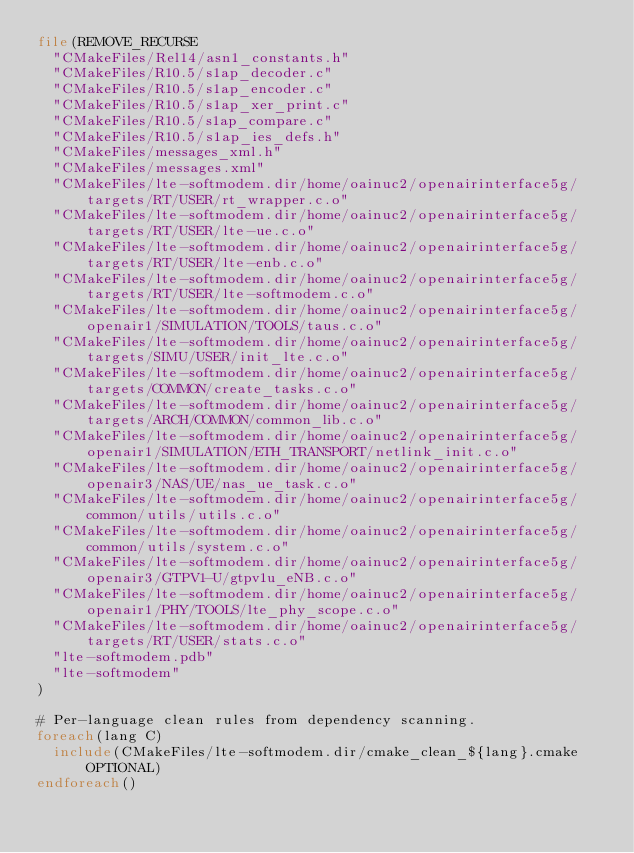<code> <loc_0><loc_0><loc_500><loc_500><_CMake_>file(REMOVE_RECURSE
  "CMakeFiles/Rel14/asn1_constants.h"
  "CMakeFiles/R10.5/s1ap_decoder.c"
  "CMakeFiles/R10.5/s1ap_encoder.c"
  "CMakeFiles/R10.5/s1ap_xer_print.c"
  "CMakeFiles/R10.5/s1ap_compare.c"
  "CMakeFiles/R10.5/s1ap_ies_defs.h"
  "CMakeFiles/messages_xml.h"
  "CMakeFiles/messages.xml"
  "CMakeFiles/lte-softmodem.dir/home/oainuc2/openairinterface5g/targets/RT/USER/rt_wrapper.c.o"
  "CMakeFiles/lte-softmodem.dir/home/oainuc2/openairinterface5g/targets/RT/USER/lte-ue.c.o"
  "CMakeFiles/lte-softmodem.dir/home/oainuc2/openairinterface5g/targets/RT/USER/lte-enb.c.o"
  "CMakeFiles/lte-softmodem.dir/home/oainuc2/openairinterface5g/targets/RT/USER/lte-softmodem.c.o"
  "CMakeFiles/lte-softmodem.dir/home/oainuc2/openairinterface5g/openair1/SIMULATION/TOOLS/taus.c.o"
  "CMakeFiles/lte-softmodem.dir/home/oainuc2/openairinterface5g/targets/SIMU/USER/init_lte.c.o"
  "CMakeFiles/lte-softmodem.dir/home/oainuc2/openairinterface5g/targets/COMMON/create_tasks.c.o"
  "CMakeFiles/lte-softmodem.dir/home/oainuc2/openairinterface5g/targets/ARCH/COMMON/common_lib.c.o"
  "CMakeFiles/lte-softmodem.dir/home/oainuc2/openairinterface5g/openair1/SIMULATION/ETH_TRANSPORT/netlink_init.c.o"
  "CMakeFiles/lte-softmodem.dir/home/oainuc2/openairinterface5g/openair3/NAS/UE/nas_ue_task.c.o"
  "CMakeFiles/lte-softmodem.dir/home/oainuc2/openairinterface5g/common/utils/utils.c.o"
  "CMakeFiles/lte-softmodem.dir/home/oainuc2/openairinterface5g/common/utils/system.c.o"
  "CMakeFiles/lte-softmodem.dir/home/oainuc2/openairinterface5g/openair3/GTPV1-U/gtpv1u_eNB.c.o"
  "CMakeFiles/lte-softmodem.dir/home/oainuc2/openairinterface5g/openair1/PHY/TOOLS/lte_phy_scope.c.o"
  "CMakeFiles/lte-softmodem.dir/home/oainuc2/openairinterface5g/targets/RT/USER/stats.c.o"
  "lte-softmodem.pdb"
  "lte-softmodem"
)

# Per-language clean rules from dependency scanning.
foreach(lang C)
  include(CMakeFiles/lte-softmodem.dir/cmake_clean_${lang}.cmake OPTIONAL)
endforeach()
</code> 